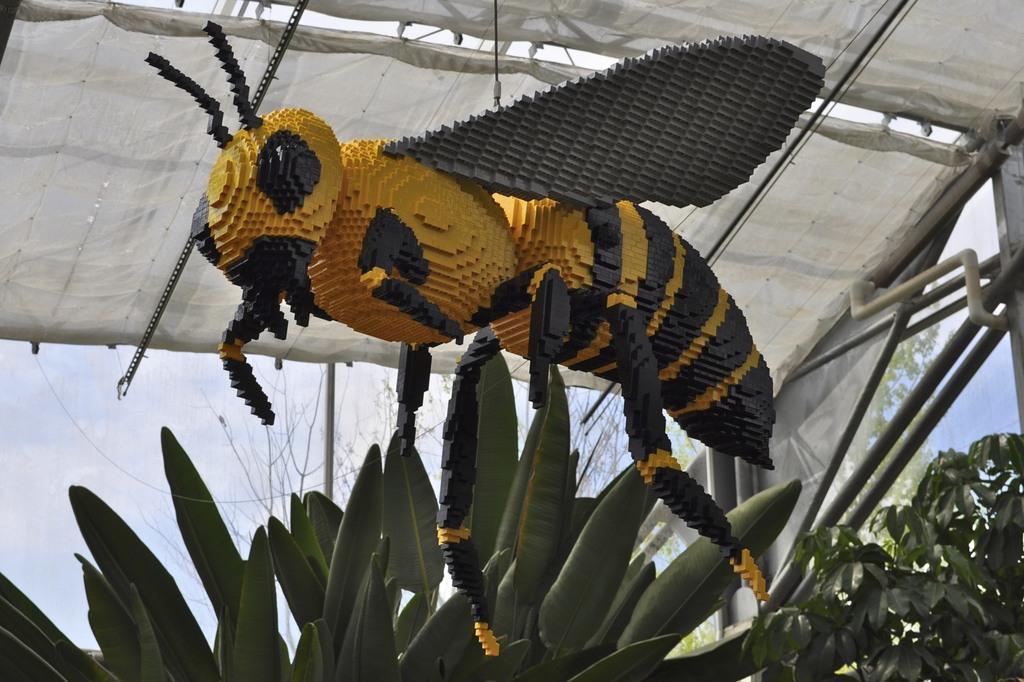How would you summarize this image in a sentence or two? In this picture there is a yellow and black color honey bee statue hanging from the white curtain ceiling shed. On the bottom front side there are some plants. 